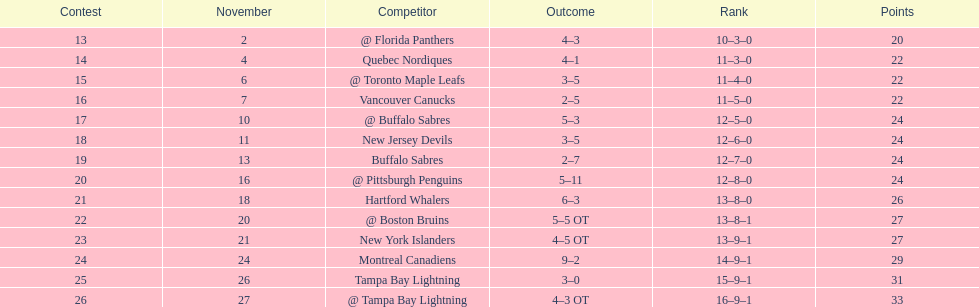Who had the most assists on the 1993-1994 flyers? Mark Recchi. 